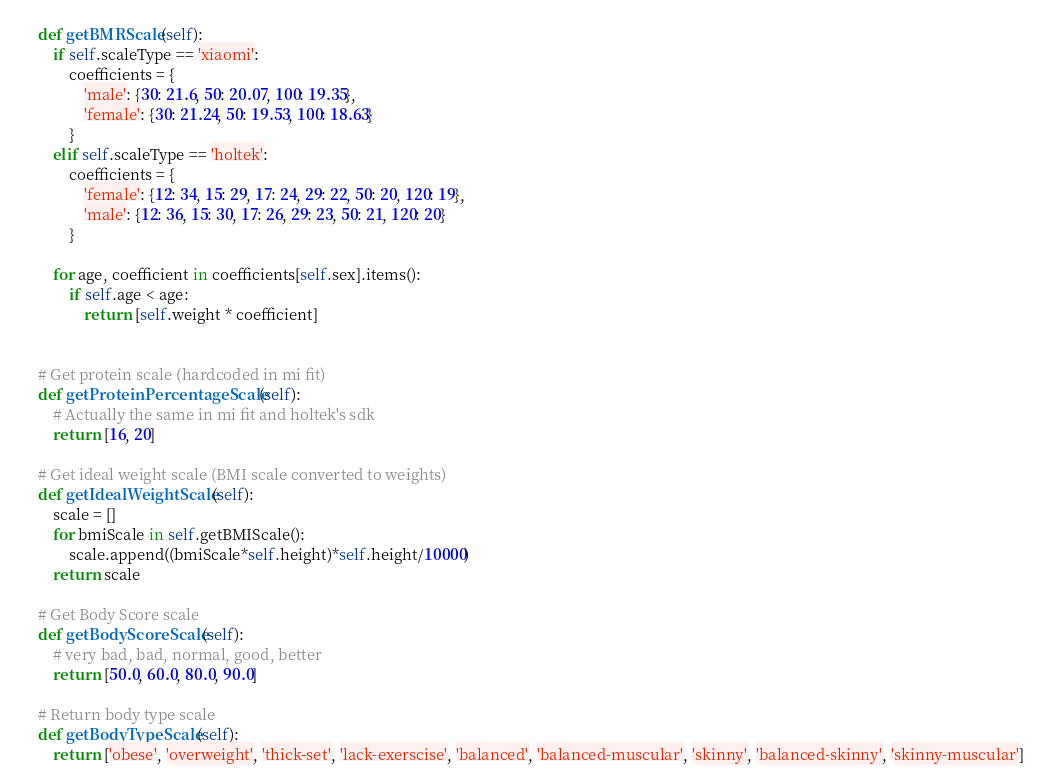<code> <loc_0><loc_0><loc_500><loc_500><_Python_>    def getBMRScale(self):
        if self.scaleType == 'xiaomi':
            coefficients = {
                'male': {30: 21.6, 50: 20.07, 100: 19.35},
                'female': {30: 21.24, 50: 19.53, 100: 18.63}
            }
        elif self.scaleType == 'holtek':
            coefficients = {
                'female': {12: 34, 15: 29, 17: 24, 29: 22, 50: 20, 120: 19},
                'male': {12: 36, 15: 30, 17: 26, 29: 23, 50: 21, 120: 20}
            }

        for age, coefficient in coefficients[self.sex].items():
            if self.age < age:
                return [self.weight * coefficient]


    # Get protein scale (hardcoded in mi fit)
    def getProteinPercentageScale(self):
        # Actually the same in mi fit and holtek's sdk
        return [16, 20]

    # Get ideal weight scale (BMI scale converted to weights)
    def getIdealWeightScale(self):
        scale = []
        for bmiScale in self.getBMIScale():
            scale.append((bmiScale*self.height)*self.height/10000)
        return scale

    # Get Body Score scale
    def getBodyScoreScale(self):
        # very bad, bad, normal, good, better
        return [50.0, 60.0, 80.0, 90.0]

    # Return body type scale
    def getBodyTypeScale(self):
        return ['obese', 'overweight', 'thick-set', 'lack-exerscise', 'balanced', 'balanced-muscular', 'skinny', 'balanced-skinny', 'skinny-muscular']

</code> 